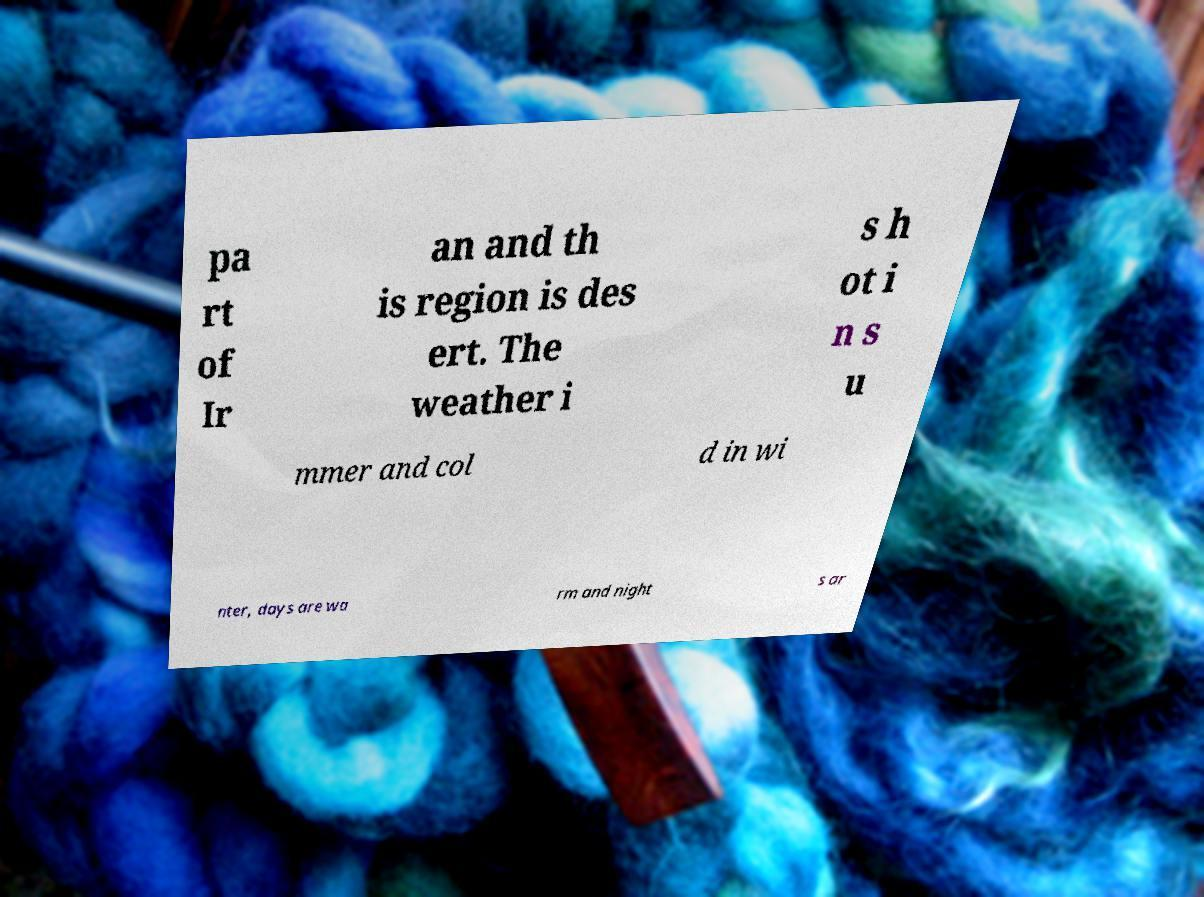Could you assist in decoding the text presented in this image and type it out clearly? pa rt of Ir an and th is region is des ert. The weather i s h ot i n s u mmer and col d in wi nter, days are wa rm and night s ar 